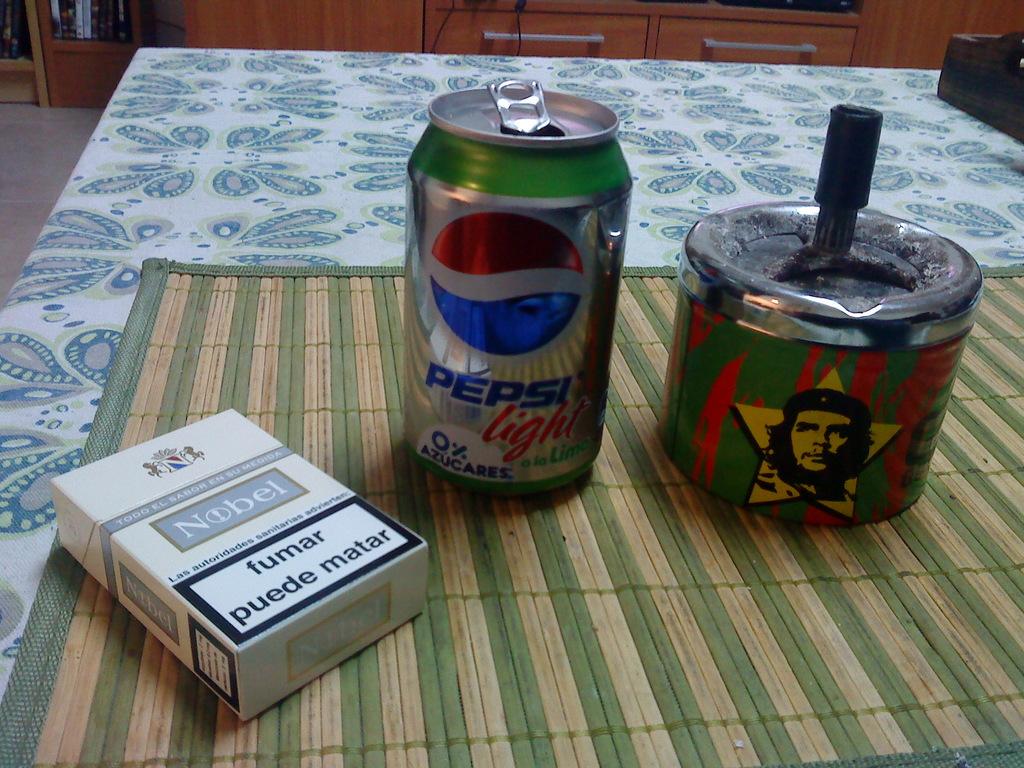What brand of soda is shown?
Your answer should be compact. Pepsi. 